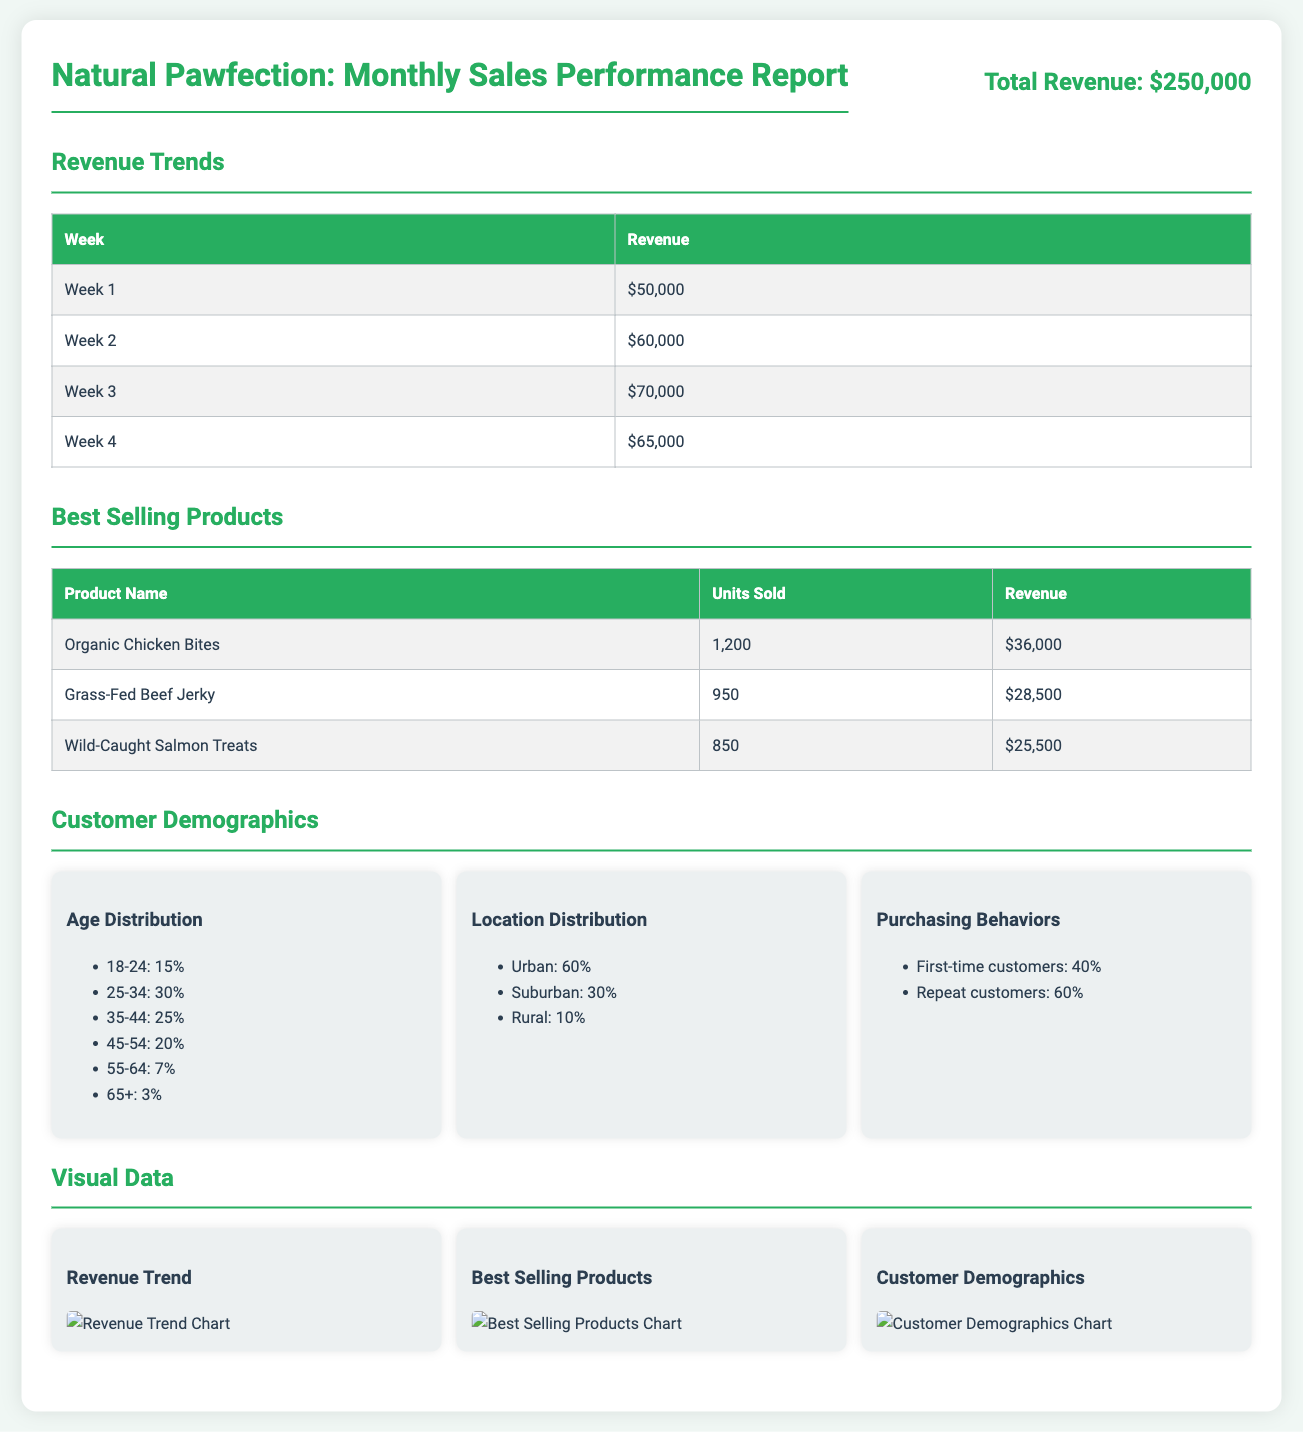What is the total revenue? The total revenue stated in the document is clearly shown in the report header as $250,000.
Answer: $250,000 Which product sold the most units? The table listing best-selling products indicates that the product with the highest units sold is Organic Chicken Bites, which sold 1,200 units.
Answer: Organic Chicken Bites What percentage of customers are repeat customers? Customer demographics show that 60% of customers are repeat customers, indicating their loyalty to the brand.
Answer: 60% Which week generated the highest revenue? The revenue trends table details revenue per week, and Week 3 has the highest revenue of $70,000.
Answer: Week 3 What is the age distribution percentage for customers aged 25-34? The customer demographics section lists the age distribution, and customers aged 25-34 make up 30% of the demographic.
Answer: 30% How many units of Grass-Fed Beef Jerky were sold? From the best-selling products table, the figure for Grass-Fed Beef Jerky sold is shown as 950 units.
Answer: 950 What is the urban customer distribution percentage? The location distribution in the demographics shows that urban customers account for 60%.
Answer: 60% Which best-selling product generated the highest revenue? The best-selling products table reveals that Organic Chicken Bites generated the highest revenue of $36,000.
Answer: Organic Chicken Bites 